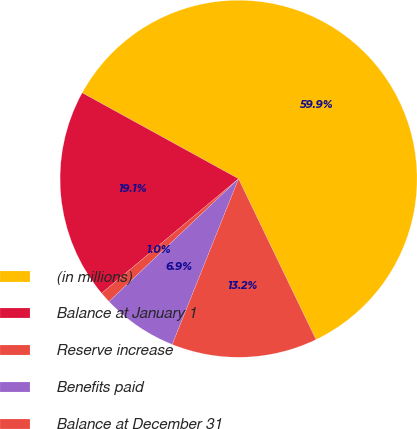Convert chart to OTSL. <chart><loc_0><loc_0><loc_500><loc_500><pie_chart><fcel>(in millions)<fcel>Balance at January 1<fcel>Reserve increase<fcel>Benefits paid<fcel>Balance at December 31<nl><fcel>59.86%<fcel>19.08%<fcel>0.99%<fcel>6.87%<fcel>13.2%<nl></chart> 